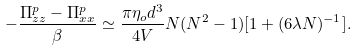<formula> <loc_0><loc_0><loc_500><loc_500>- \frac { \Pi _ { z z } ^ { p } - \Pi _ { x x } ^ { p } } { \beta } \simeq \frac { \pi \eta _ { o } d ^ { 3 } } { 4 V } N ( N ^ { 2 } - 1 ) [ 1 + ( 6 \lambda N ) ^ { - 1 } ] .</formula> 